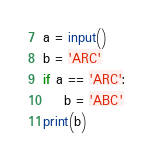<code> <loc_0><loc_0><loc_500><loc_500><_Python_>a = input()
b = 'ARC'
if a == 'ARC':
    b = 'ABC'
print(b)</code> 